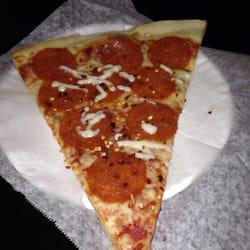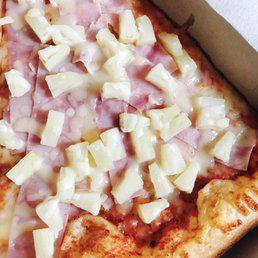The first image is the image on the left, the second image is the image on the right. For the images displayed, is the sentence "There is a single slice of pizza on a paper plate." factually correct? Answer yes or no. Yes. The first image is the image on the left, the second image is the image on the right. Assess this claim about the two images: "A whole pizza sits in a cardboard box in one of the images.". Correct or not? Answer yes or no. No. 